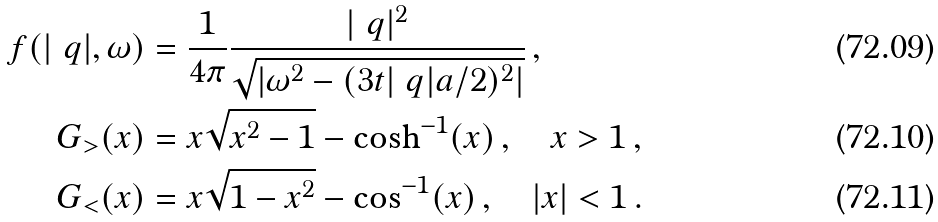Convert formula to latex. <formula><loc_0><loc_0><loc_500><loc_500>f ( | \ q | , \omega ) & = \frac { 1 } { 4 \pi } \frac { | \ q | ^ { 2 } } { \sqrt { | \omega ^ { 2 } - ( 3 t | \ q | a / 2 ) ^ { 2 } | } } \, , \\ G _ { > } ( x ) & = x \sqrt { x ^ { 2 } - 1 } - \cosh ^ { - 1 } ( x ) \, , \quad x > 1 \, , \\ G _ { < } ( x ) & = x \sqrt { 1 - x ^ { 2 } } - \cos ^ { - 1 } ( x ) \, , \quad | x | < 1 \, .</formula> 